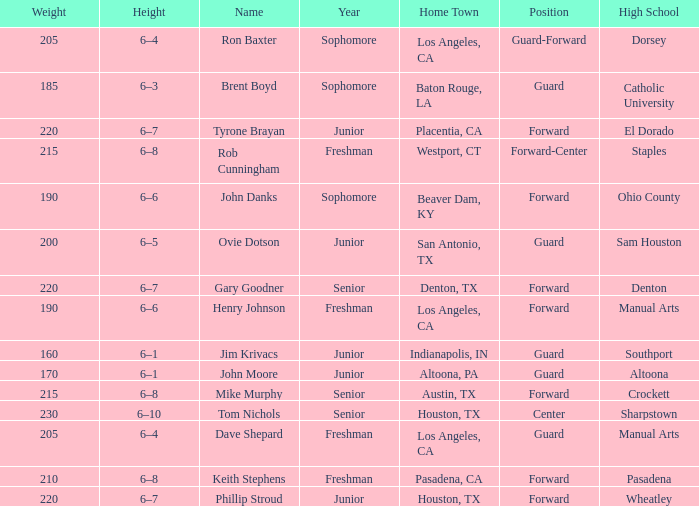What is the Name with a Year with freshman, and a Home Town with los angeles, ca, and a Height of 6–4? Dave Shepard. 